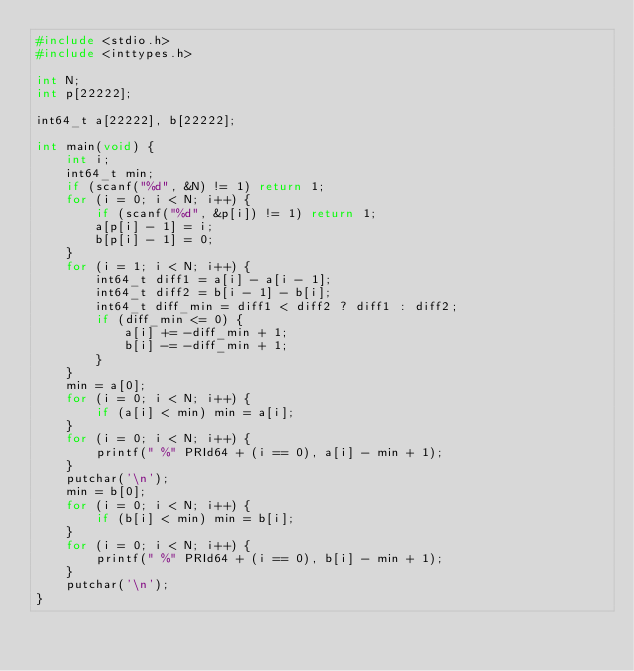Convert code to text. <code><loc_0><loc_0><loc_500><loc_500><_C_>#include <stdio.h>
#include <inttypes.h>

int N;
int p[22222];

int64_t a[22222], b[22222];

int main(void) {
	int i;
	int64_t min;
	if (scanf("%d", &N) != 1) return 1;
	for (i = 0; i < N; i++) {
		if (scanf("%d", &p[i]) != 1) return 1;
		a[p[i] - 1] = i;
		b[p[i] - 1] = 0;
	}
	for (i = 1; i < N; i++) {
		int64_t diff1 = a[i] - a[i - 1];
		int64_t diff2 = b[i - 1] - b[i];
		int64_t diff_min = diff1 < diff2 ? diff1 : diff2;
		if (diff_min <= 0) {
			a[i] += -diff_min + 1;
			b[i] -= -diff_min + 1;
		}
	}
	min = a[0];
	for (i = 0; i < N; i++) {
		if (a[i] < min) min = a[i];
	}
	for (i = 0; i < N; i++) {
		printf(" %" PRId64 + (i == 0), a[i] - min + 1);
	}
	putchar('\n');
	min = b[0];
	for (i = 0; i < N; i++) {
		if (b[i] < min) min = b[i];
	}
	for (i = 0; i < N; i++) {
		printf(" %" PRId64 + (i == 0), b[i] - min + 1);
	}
	putchar('\n');
}
</code> 